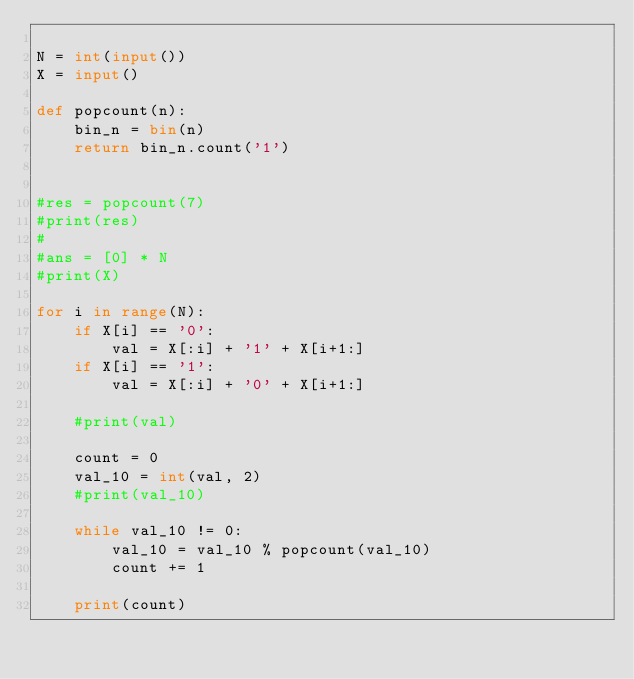Convert code to text. <code><loc_0><loc_0><loc_500><loc_500><_Python_>
N = int(input())
X = input()

def popcount(n):
    bin_n = bin(n)
    return bin_n.count('1')


#res = popcount(7)
#print(res)
#
#ans = [0] * N
#print(X)

for i in range(N):
    if X[i] == '0':
        val = X[:i] + '1' + X[i+1:]
    if X[i] == '1':
        val = X[:i] + '0' + X[i+1:]

    #print(val)

    count = 0
    val_10 = int(val, 2)
    #print(val_10)

    while val_10 != 0:
        val_10 = val_10 % popcount(val_10)
        count += 1

    print(count)
</code> 